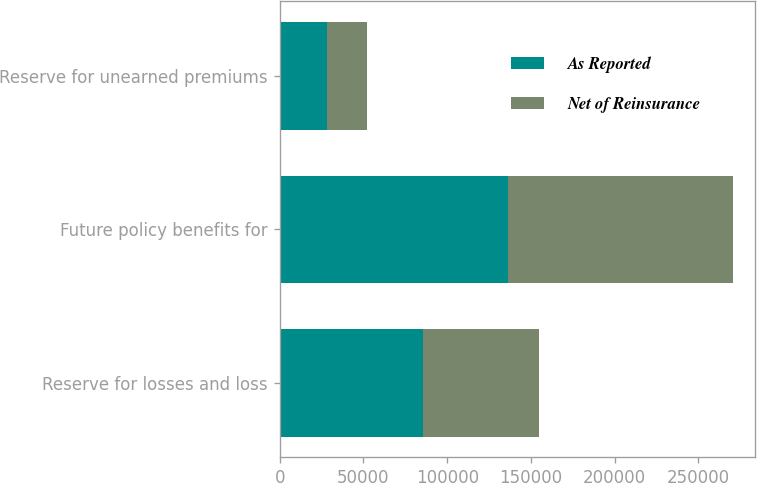Convert chart to OTSL. <chart><loc_0><loc_0><loc_500><loc_500><stacked_bar_chart><ecel><fcel>Reserve for losses and loss<fcel>Future policy benefits for<fcel>Reserve for unearned premiums<nl><fcel>As Reported<fcel>85500<fcel>136068<fcel>28022<nl><fcel>Net of Reinsurance<fcel>69288<fcel>134461<fcel>24029<nl></chart> 